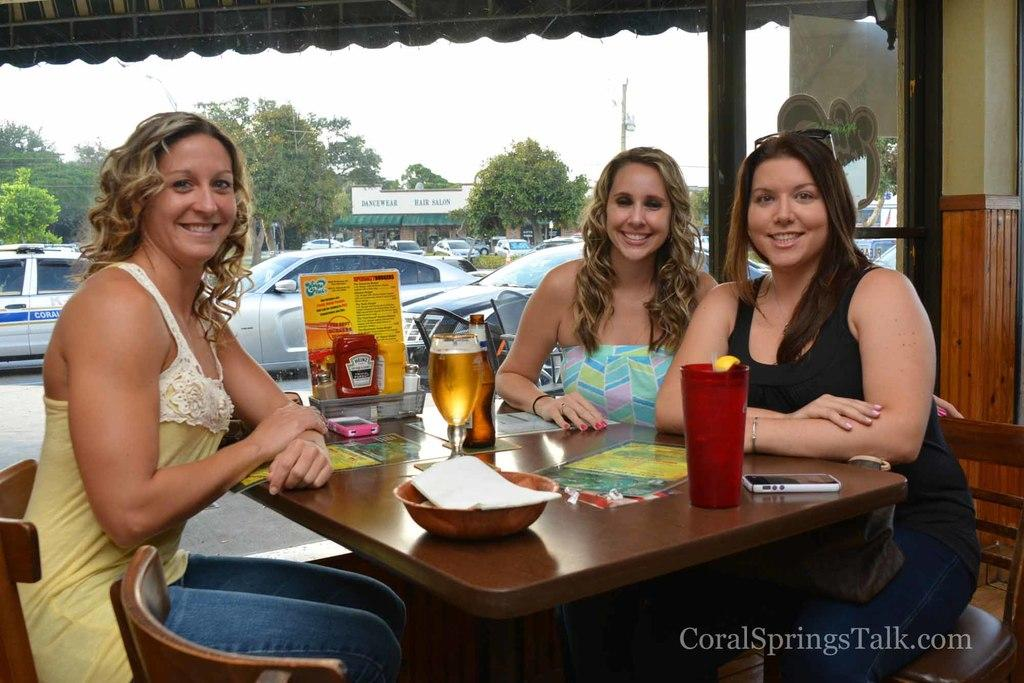What are the people in the image doing? People are sitting on chairs in the image. What objects can be seen on the table? There is a glass, a phone, a bowl, and a paper on the table. What is visible in the background of the image? Trees and a car are visible in the background of the image. What type of afterthought can be seen in the image? There is no afterthought present in the image. What color is the flesh of the people in the image? There is no flesh visible in the image, as it only shows people sitting on chairs and objects on a table. 